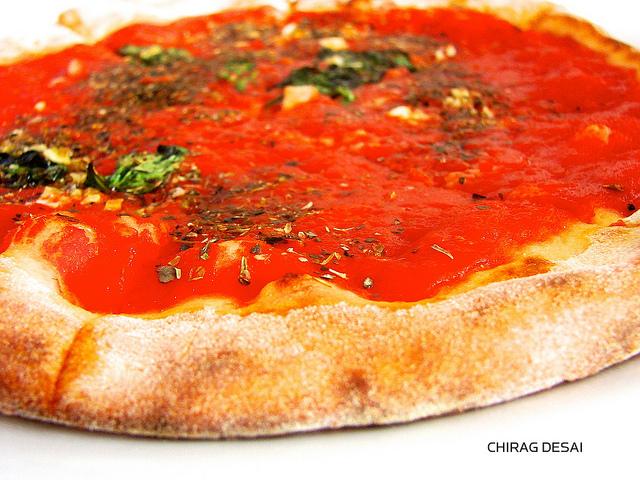Is there meat on this pizza?
Quick response, please. No. Is there too much sauce on this pizza?
Keep it brief. Yes. Does this pizza have seasoning on top?
Be succinct. Yes. 